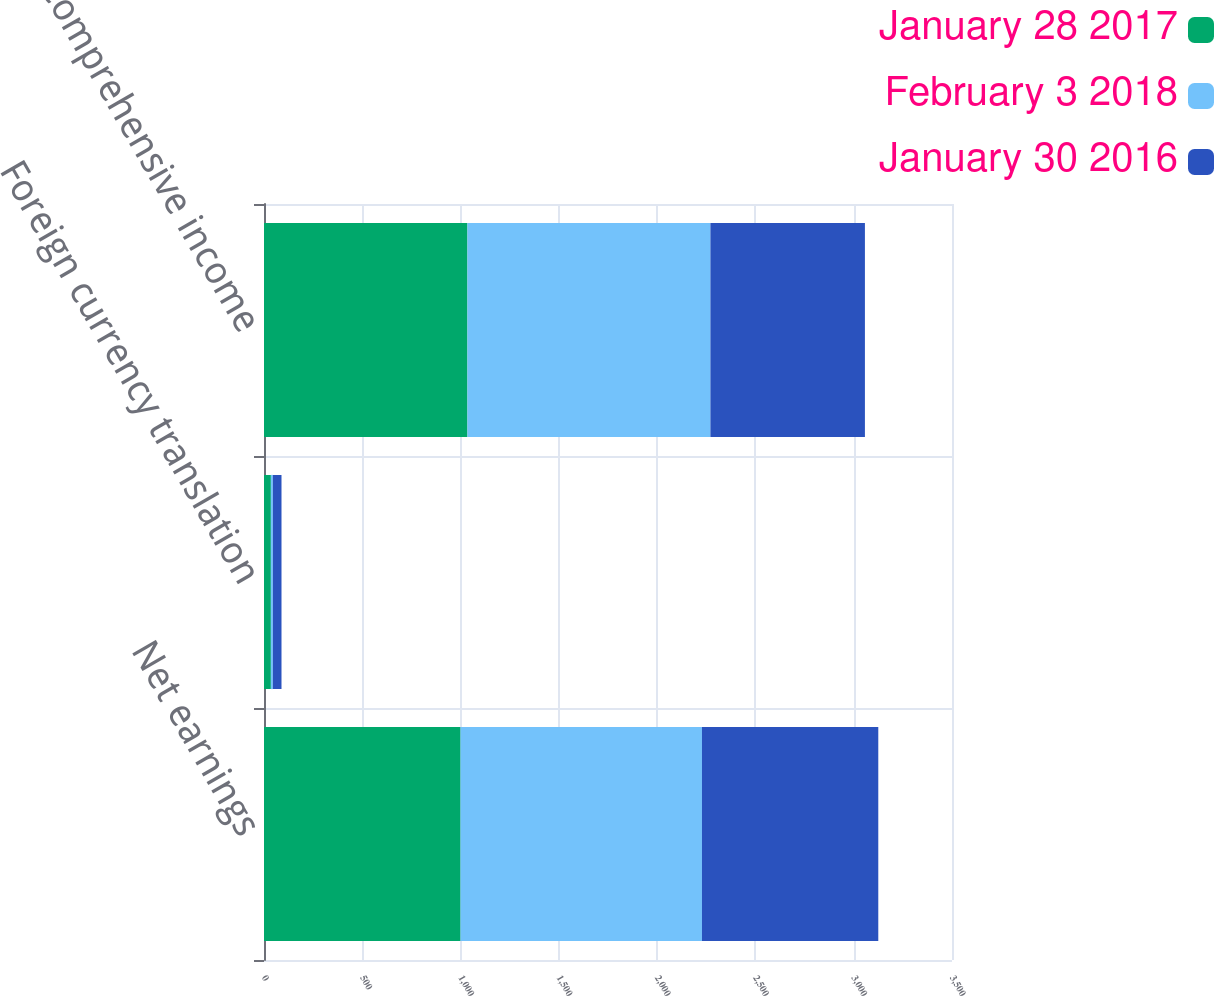Convert chart. <chart><loc_0><loc_0><loc_500><loc_500><stacked_bar_chart><ecel><fcel>Net earnings<fcel>Foreign currency translation<fcel>Comprehensive income<nl><fcel>January 28 2017<fcel>1000<fcel>35<fcel>1035<nl><fcel>February 3 2018<fcel>1228<fcel>10<fcel>1236<nl><fcel>January 30 2016<fcel>897<fcel>44<fcel>786<nl></chart> 